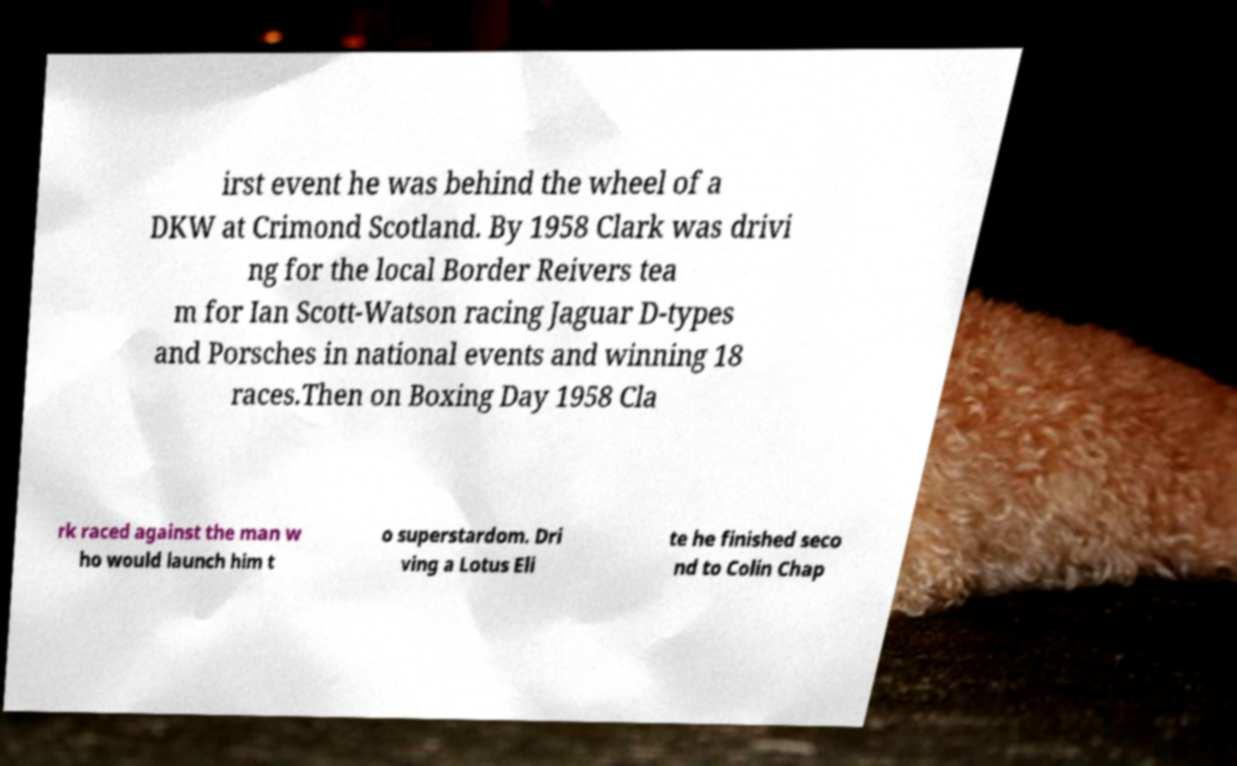Please read and relay the text visible in this image. What does it say? irst event he was behind the wheel of a DKW at Crimond Scotland. By 1958 Clark was drivi ng for the local Border Reivers tea m for Ian Scott-Watson racing Jaguar D-types and Porsches in national events and winning 18 races.Then on Boxing Day 1958 Cla rk raced against the man w ho would launch him t o superstardom. Dri ving a Lotus Eli te he finished seco nd to Colin Chap 